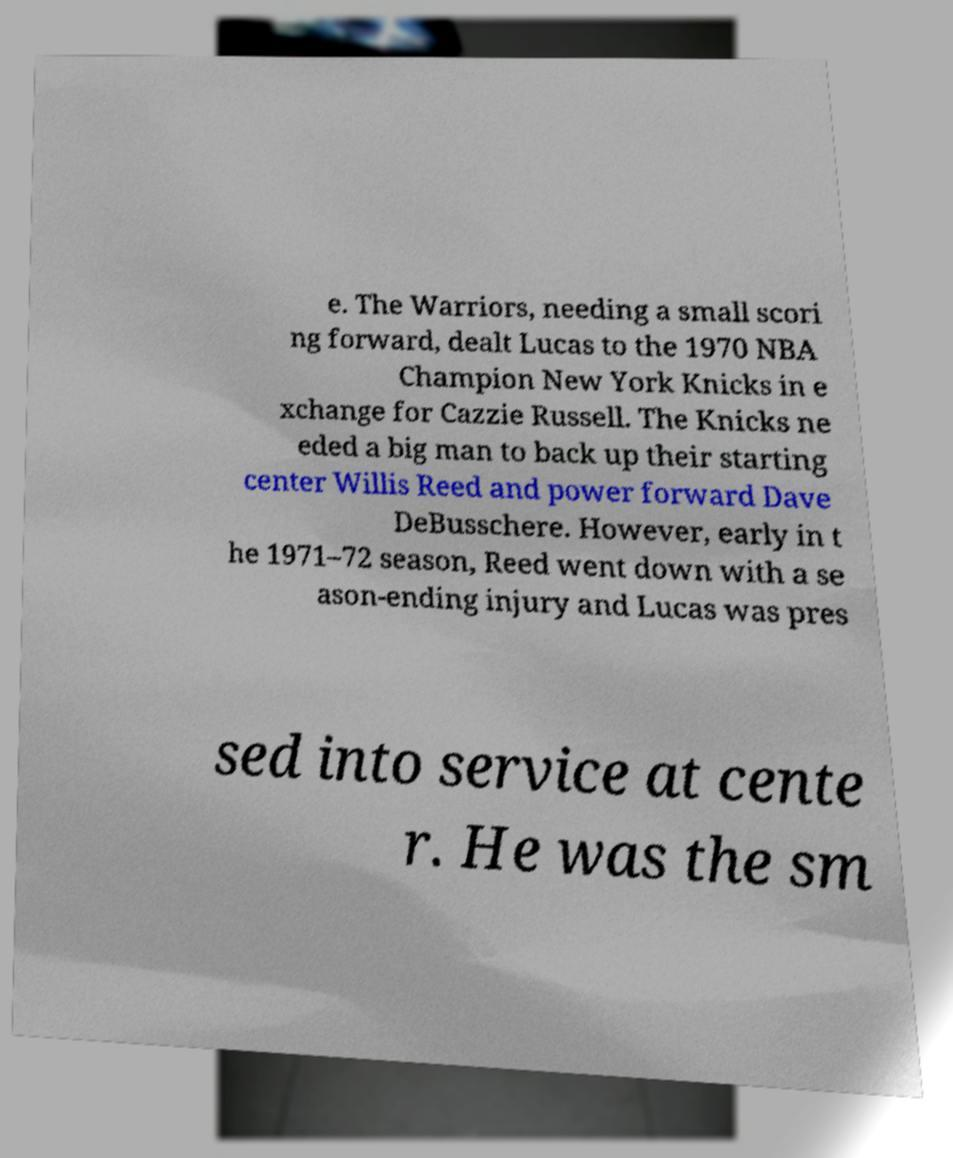I need the written content from this picture converted into text. Can you do that? e. The Warriors, needing a small scori ng forward, dealt Lucas to the 1970 NBA Champion New York Knicks in e xchange for Cazzie Russell. The Knicks ne eded a big man to back up their starting center Willis Reed and power forward Dave DeBusschere. However, early in t he 1971–72 season, Reed went down with a se ason-ending injury and Lucas was pres sed into service at cente r. He was the sm 